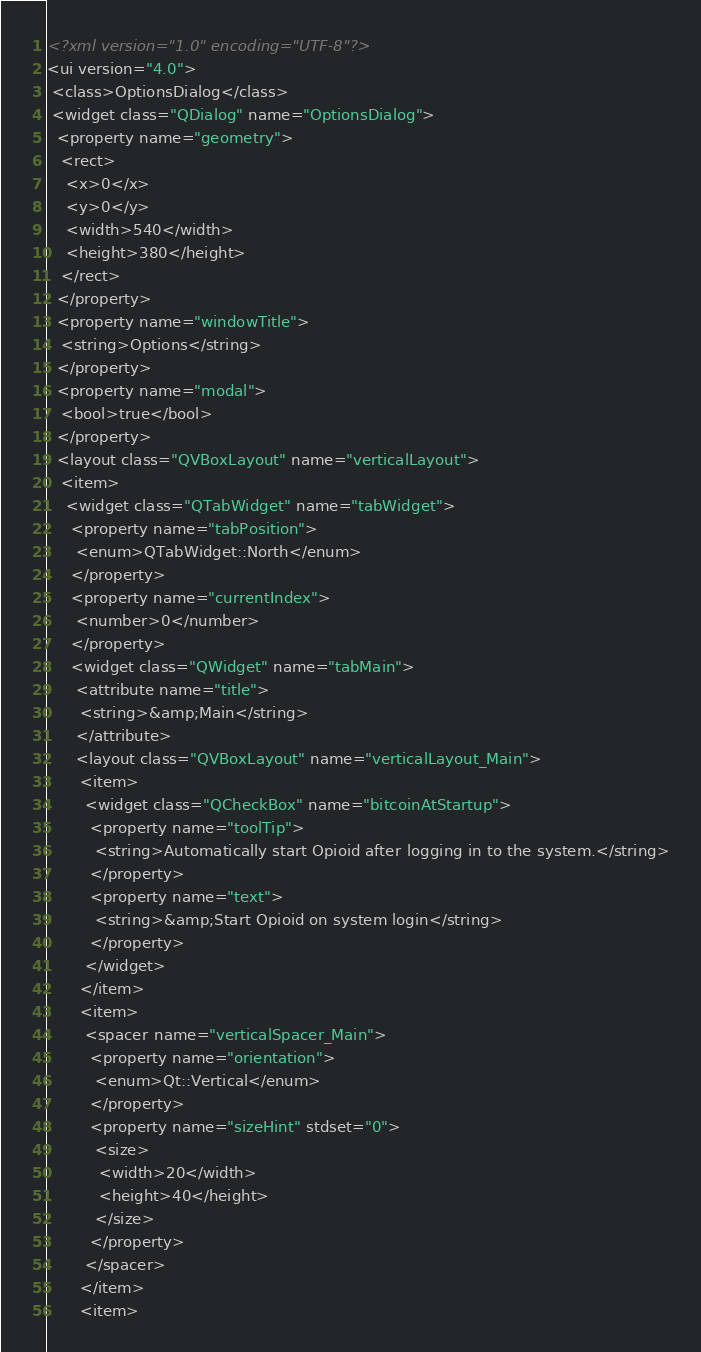Convert code to text. <code><loc_0><loc_0><loc_500><loc_500><_XML_><?xml version="1.0" encoding="UTF-8"?>
<ui version="4.0">
 <class>OptionsDialog</class>
 <widget class="QDialog" name="OptionsDialog">
  <property name="geometry">
   <rect>
    <x>0</x>
    <y>0</y>
    <width>540</width>
    <height>380</height>
   </rect>
  </property>
  <property name="windowTitle">
   <string>Options</string>
  </property>
  <property name="modal">
   <bool>true</bool>
  </property>
  <layout class="QVBoxLayout" name="verticalLayout">
   <item>
    <widget class="QTabWidget" name="tabWidget">
     <property name="tabPosition">
      <enum>QTabWidget::North</enum>
     </property>
     <property name="currentIndex">
      <number>0</number>
     </property>
     <widget class="QWidget" name="tabMain">
      <attribute name="title">
       <string>&amp;Main</string>
      </attribute>
      <layout class="QVBoxLayout" name="verticalLayout_Main">
       <item>
        <widget class="QCheckBox" name="bitcoinAtStartup">
         <property name="toolTip">
          <string>Automatically start Opioid after logging in to the system.</string>
         </property>
         <property name="text">
          <string>&amp;Start Opioid on system login</string>
         </property>
        </widget>
       </item>
       <item>
        <spacer name="verticalSpacer_Main">
         <property name="orientation">
          <enum>Qt::Vertical</enum>
         </property>
         <property name="sizeHint" stdset="0">
          <size>
           <width>20</width>
           <height>40</height>
          </size>
         </property>
        </spacer>
       </item>
       <item></code> 